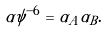<formula> <loc_0><loc_0><loc_500><loc_500>\alpha \psi ^ { - 6 } = \alpha _ { A } \alpha _ { B } .</formula> 